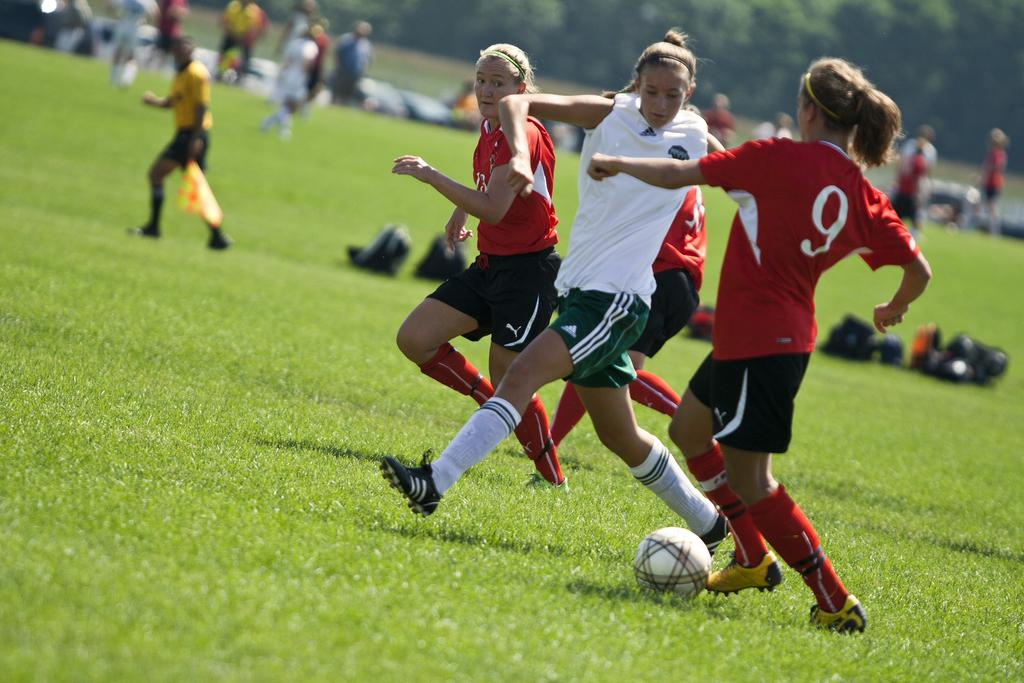<image>
Offer a succinct explanation of the picture presented. Three soccer players going for player number 9's ball. 